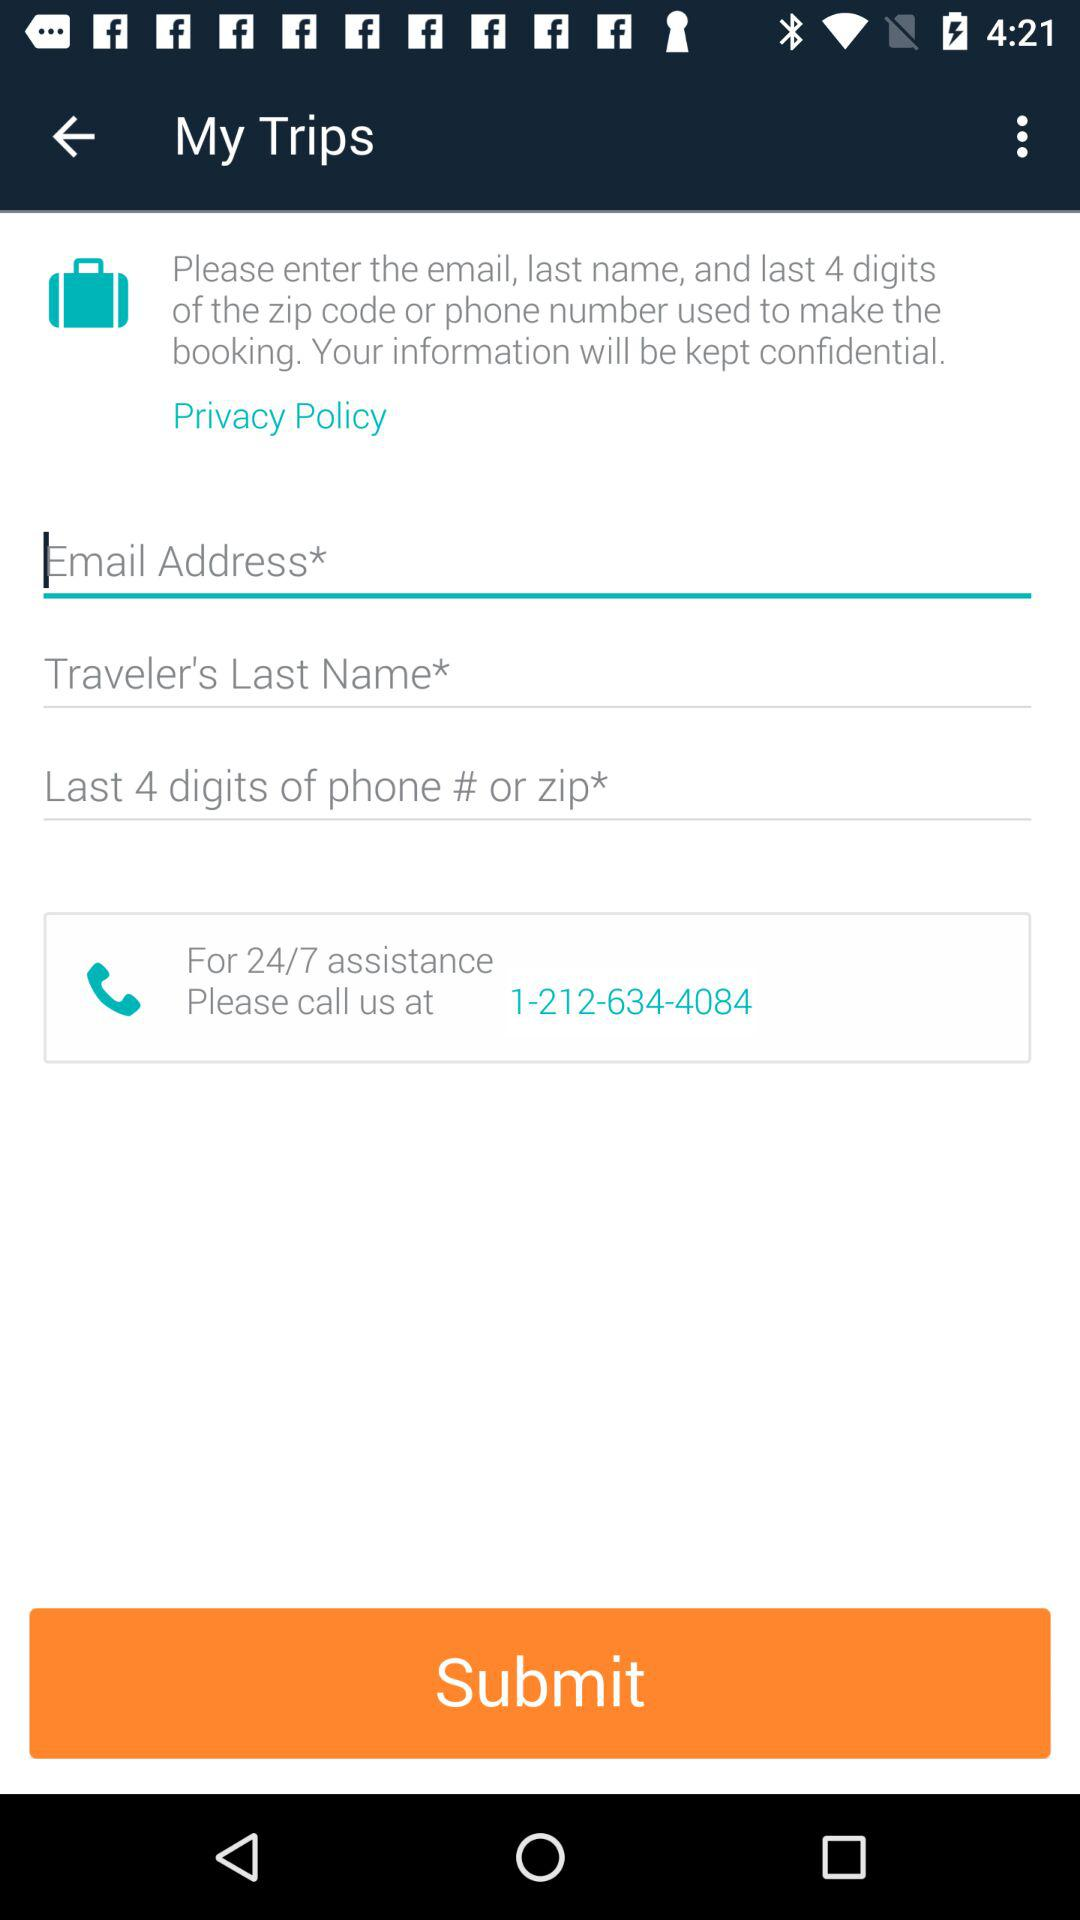How many digits are required in the last 4 digits of the phone number or zip code?
Answer the question using a single word or phrase. 4 